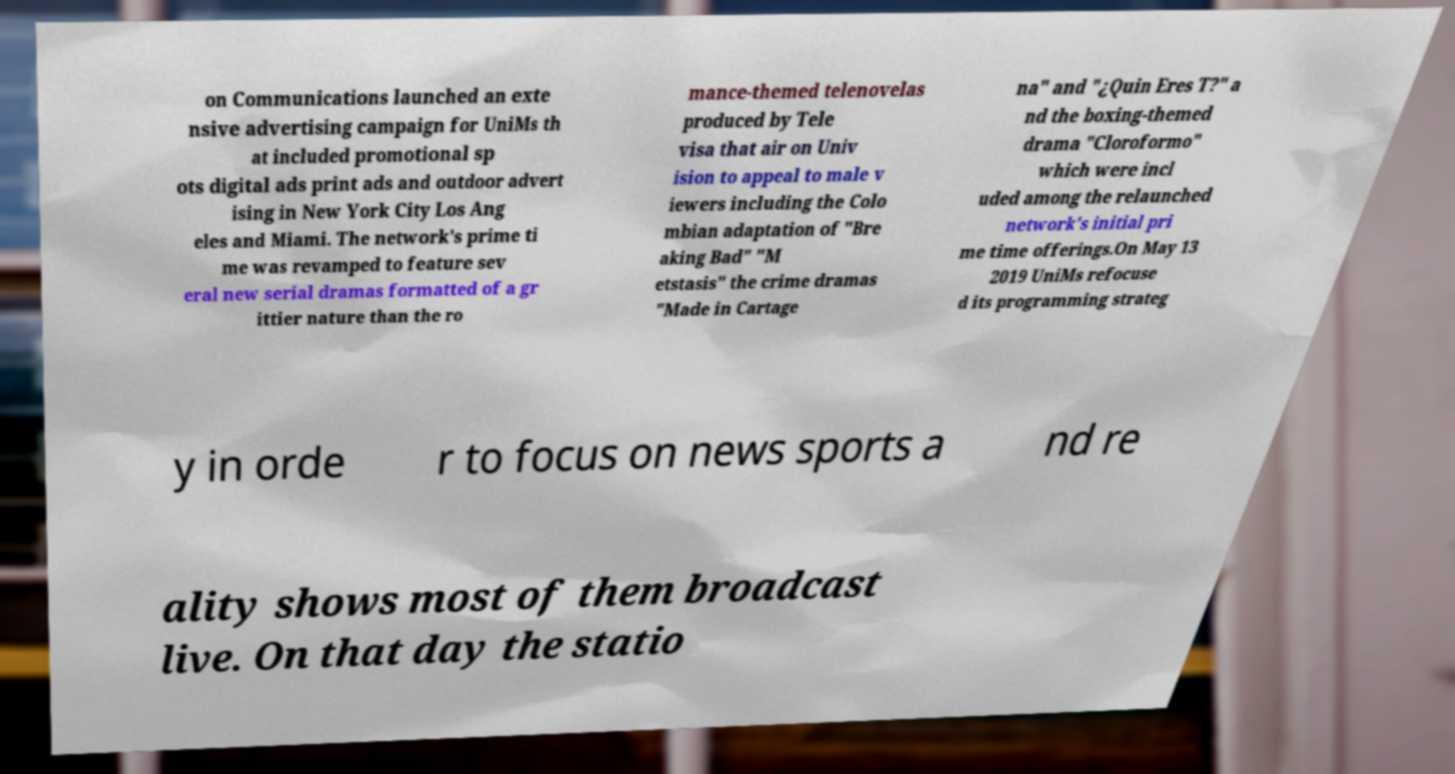I need the written content from this picture converted into text. Can you do that? on Communications launched an exte nsive advertising campaign for UniMs th at included promotional sp ots digital ads print ads and outdoor advert ising in New York City Los Ang eles and Miami. The network's prime ti me was revamped to feature sev eral new serial dramas formatted of a gr ittier nature than the ro mance-themed telenovelas produced by Tele visa that air on Univ ision to appeal to male v iewers including the Colo mbian adaptation of "Bre aking Bad" "M etstasis" the crime dramas "Made in Cartage na" and "¿Quin Eres T?" a nd the boxing-themed drama "Cloroformo" which were incl uded among the relaunched network's initial pri me time offerings.On May 13 2019 UniMs refocuse d its programming strateg y in orde r to focus on news sports a nd re ality shows most of them broadcast live. On that day the statio 